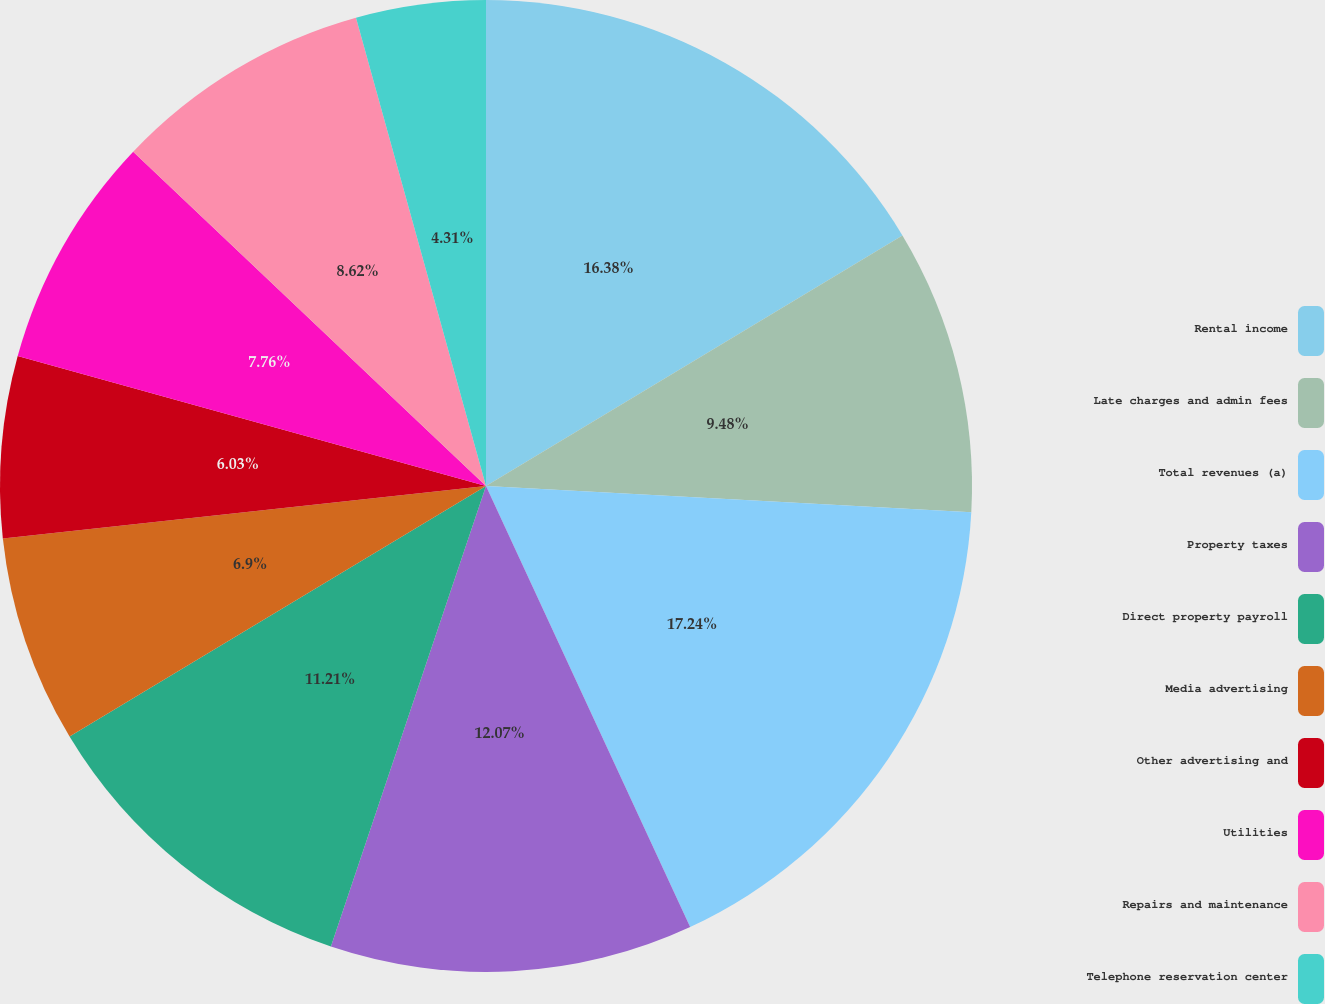<chart> <loc_0><loc_0><loc_500><loc_500><pie_chart><fcel>Rental income<fcel>Late charges and admin fees<fcel>Total revenues (a)<fcel>Property taxes<fcel>Direct property payroll<fcel>Media advertising<fcel>Other advertising and<fcel>Utilities<fcel>Repairs and maintenance<fcel>Telephone reservation center<nl><fcel>16.38%<fcel>9.48%<fcel>17.24%<fcel>12.07%<fcel>11.21%<fcel>6.9%<fcel>6.03%<fcel>7.76%<fcel>8.62%<fcel>4.31%<nl></chart> 